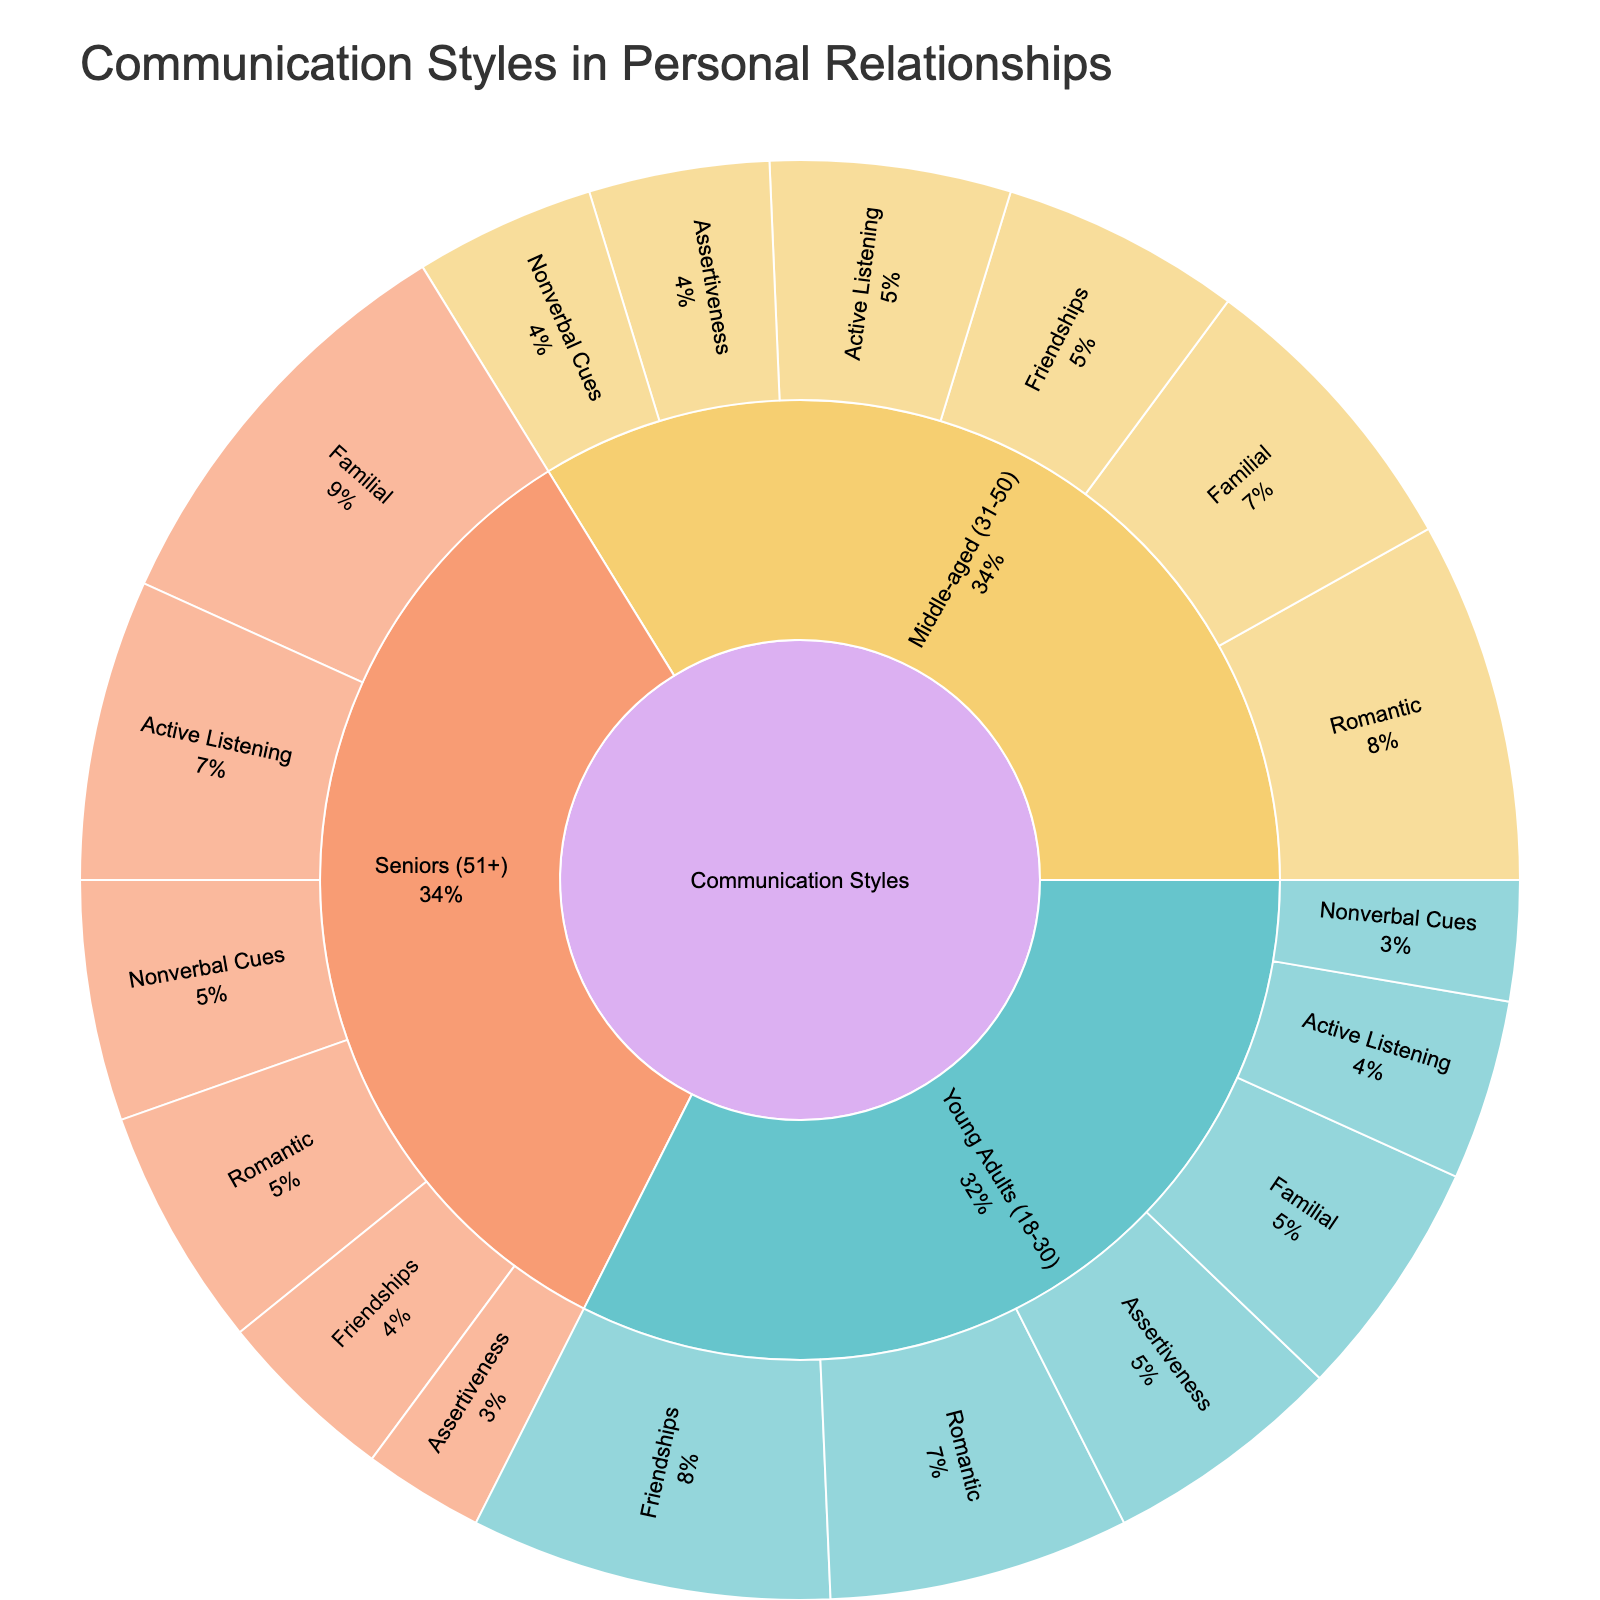what is the title of the figure? The title of the figure is usually displayed prominently at the top. By looking at the top of the plot, you can easily read the title.
Answer: Communication Styles in Personal Relationships Which age group has the highest value in familial relationships? We need to look at the "Familial" sub-category within each age group. By observing the plot, "Seniors (51+)" have the highest value in familial relationships.
Answer: Seniors (51+) What is the sum of values for assertiveness across all age groups? We need to find the values corresponding to "Assertiveness" in each age group and add them. Young Adults (18-30) have 20, Middle-aged (31-50) have 15, and Seniors (51+) have 10. So, 20 + 15 + 10 = 45.
Answer: 45 Comparing romantic relationships, which age group has the lowest value? We need to compare the values for "Romantic" sub-category among all age groups. Seniors (51+) have the lowest value with 20.
Answer: Seniors (51+) Which subcategory in the middle-aged group has the lowest value? We look at the "Middle-aged (31-50)" sub-category and find the lowest value. "Friendships" has the lowest value with 20.
Answer: Friendships What percentage of the total value does active listening represent for seniors (51+)? First, find the total value for seniors by summing their values (Romantic: 20, Familial: 35, Friendships: 15, Active Listening: 25, Assertiveness: 10, Nonverbal Cues: 20) which equals 125. Then, the value for Active Listening is 25. So the percentage is (25 / 125) * 100 = 20%.
Answer: 20% How does the value of nonverbal cues for young adults compare to that for seniors? The value of Nonverbal Cues for Young Adults (18-30) is 10, and for Seniors (51+) it is 20. By observing, the young adults' value is less than that of the seniors.
Answer: Less Identify the communication style with the highest value among young adults? We need to look at the subcategories within "Young Adults (18-30)" and find the one with the highest value. "Friendships" has the highest value with 30.
Answer: Friendships 